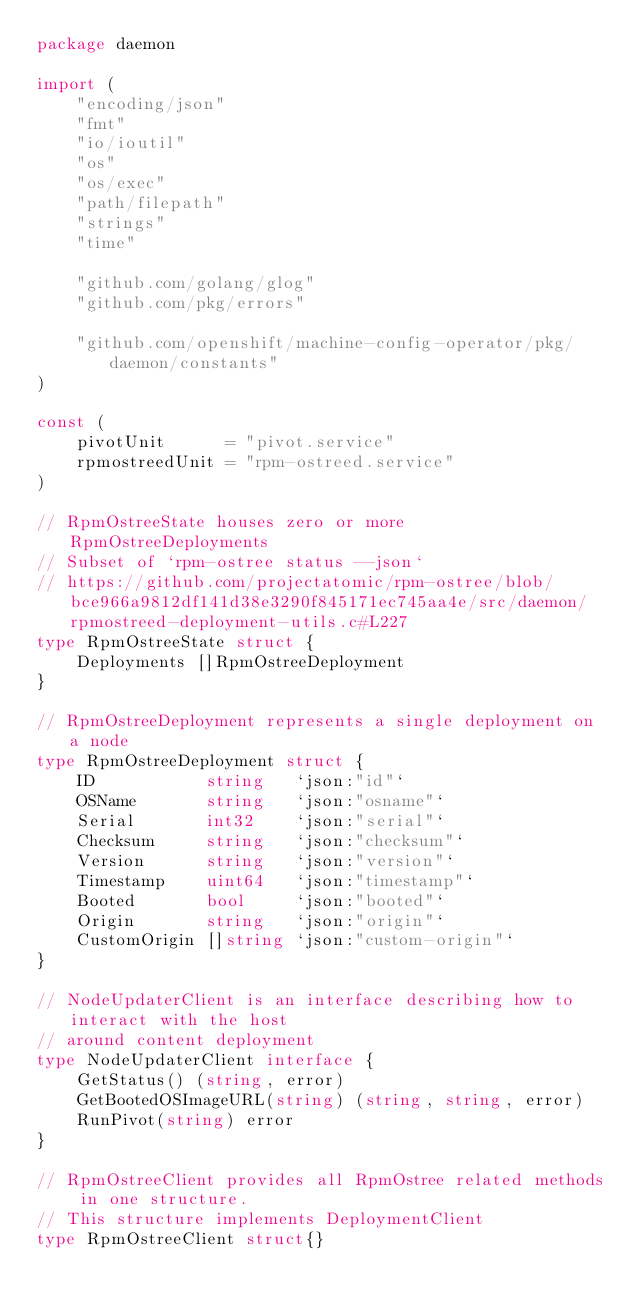<code> <loc_0><loc_0><loc_500><loc_500><_Go_>package daemon

import (
	"encoding/json"
	"fmt"
	"io/ioutil"
	"os"
	"os/exec"
	"path/filepath"
	"strings"
	"time"

	"github.com/golang/glog"
	"github.com/pkg/errors"

	"github.com/openshift/machine-config-operator/pkg/daemon/constants"
)

const (
	pivotUnit      = "pivot.service"
	rpmostreedUnit = "rpm-ostreed.service"
)

// RpmOstreeState houses zero or more RpmOstreeDeployments
// Subset of `rpm-ostree status --json`
// https://github.com/projectatomic/rpm-ostree/blob/bce966a9812df141d38e3290f845171ec745aa4e/src/daemon/rpmostreed-deployment-utils.c#L227
type RpmOstreeState struct {
	Deployments []RpmOstreeDeployment
}

// RpmOstreeDeployment represents a single deployment on a node
type RpmOstreeDeployment struct {
	ID           string   `json:"id"`
	OSName       string   `json:"osname"`
	Serial       int32    `json:"serial"`
	Checksum     string   `json:"checksum"`
	Version      string   `json:"version"`
	Timestamp    uint64   `json:"timestamp"`
	Booted       bool     `json:"booted"`
	Origin       string   `json:"origin"`
	CustomOrigin []string `json:"custom-origin"`
}

// NodeUpdaterClient is an interface describing how to interact with the host
// around content deployment
type NodeUpdaterClient interface {
	GetStatus() (string, error)
	GetBootedOSImageURL(string) (string, string, error)
	RunPivot(string) error
}

// RpmOstreeClient provides all RpmOstree related methods in one structure.
// This structure implements DeploymentClient
type RpmOstreeClient struct{}
</code> 